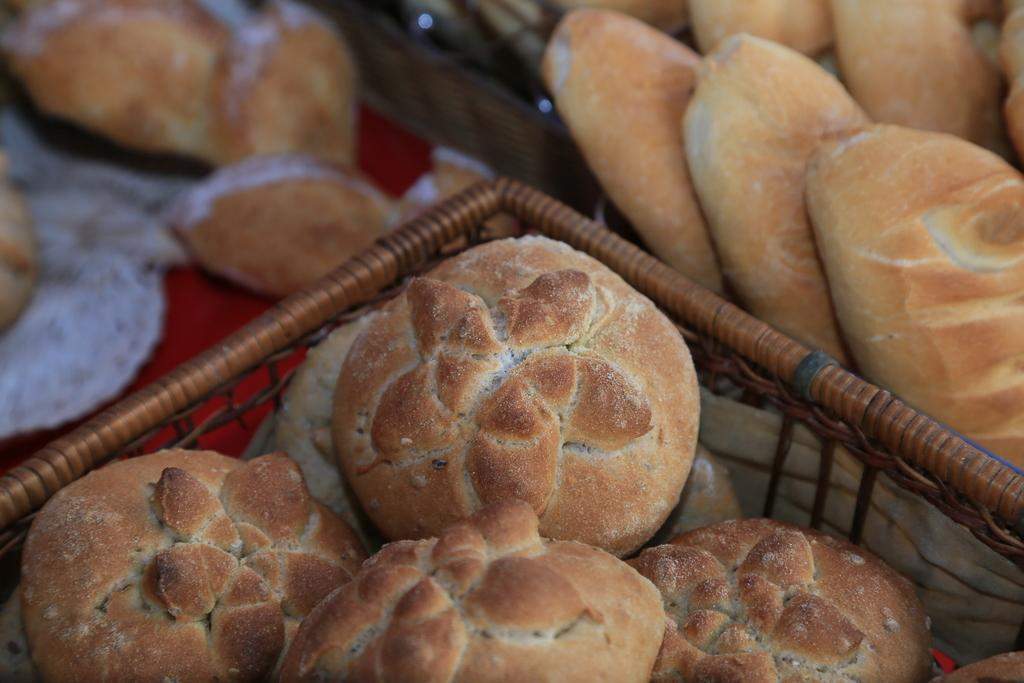What type of food can be seen in the image? There are baked items in the image. How are the baked items stored or displayed? The baked items are kept in a brown-colored thing. Can you describe the baked items in the top right corner of the image? There are buns in the top right corner of the image. What type of cord is used to hang the deer in the image? There is no cord or deer present in the image; it features baked items kept in a brown-colored thing. What kind of bait is used to attract the fish in the image? There is no fish or bait present in the image; it features baked items kept in a brown-colored thing. 